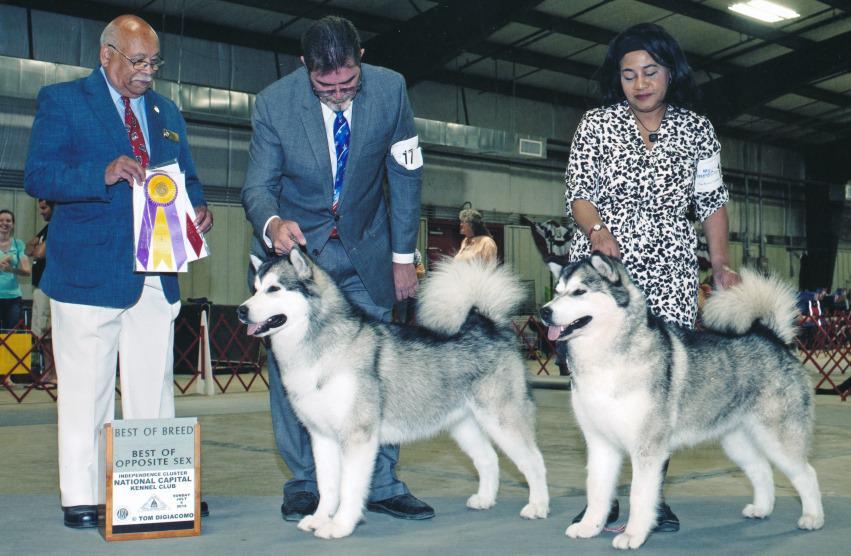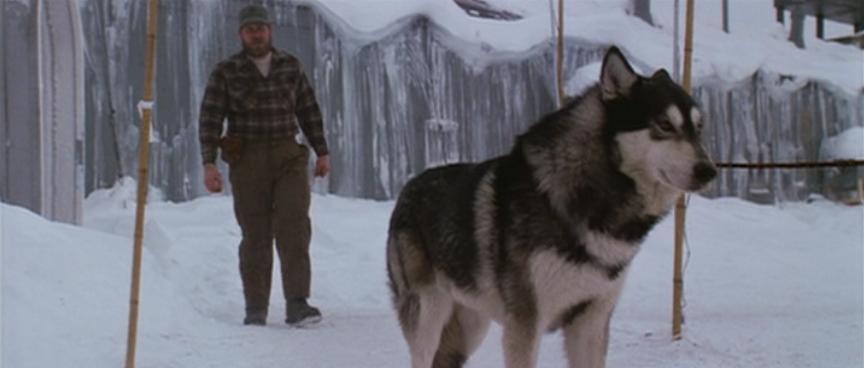The first image is the image on the left, the second image is the image on the right. Assess this claim about the two images: "One of the images shows exactly five puppies.". Correct or not? Answer yes or no. No. The first image is the image on the left, the second image is the image on the right. For the images shown, is this caption "At least one person is standing directly next to a standing, leftward-facing husky in the left image." true? Answer yes or no. Yes. 